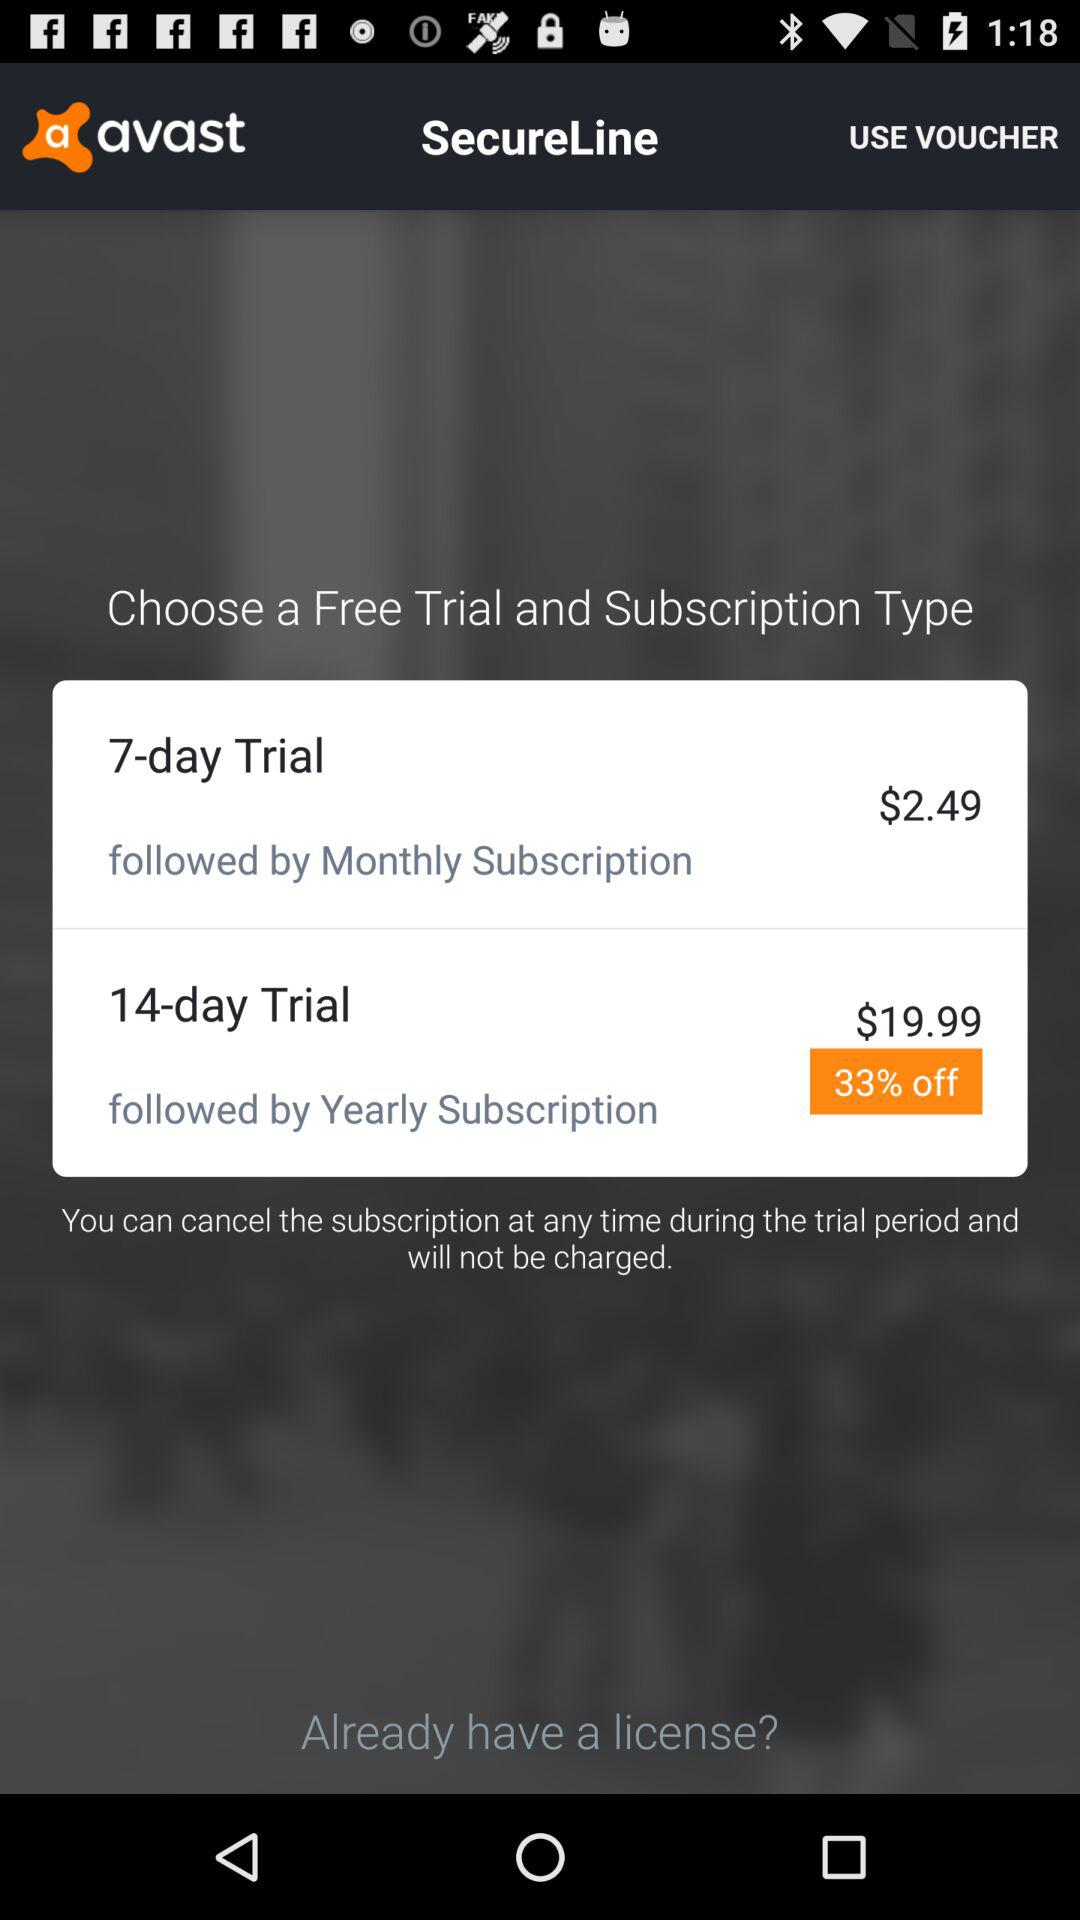How many days is the longer trial?
Answer the question using a single word or phrase. 14 